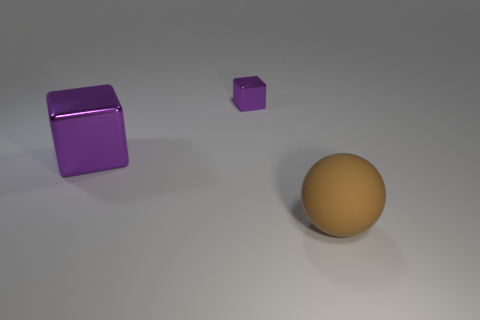Subtract 1 cubes. How many cubes are left? 1 Add 2 cyan shiny spheres. How many objects exist? 5 Subtract 0 purple cylinders. How many objects are left? 3 Subtract all blocks. How many objects are left? 1 Subtract all red blocks. Subtract all purple cylinders. How many blocks are left? 2 Subtract all small purple shiny cubes. Subtract all brown rubber balls. How many objects are left? 1 Add 2 large metallic objects. How many large metallic objects are left? 3 Add 2 metal things. How many metal things exist? 4 